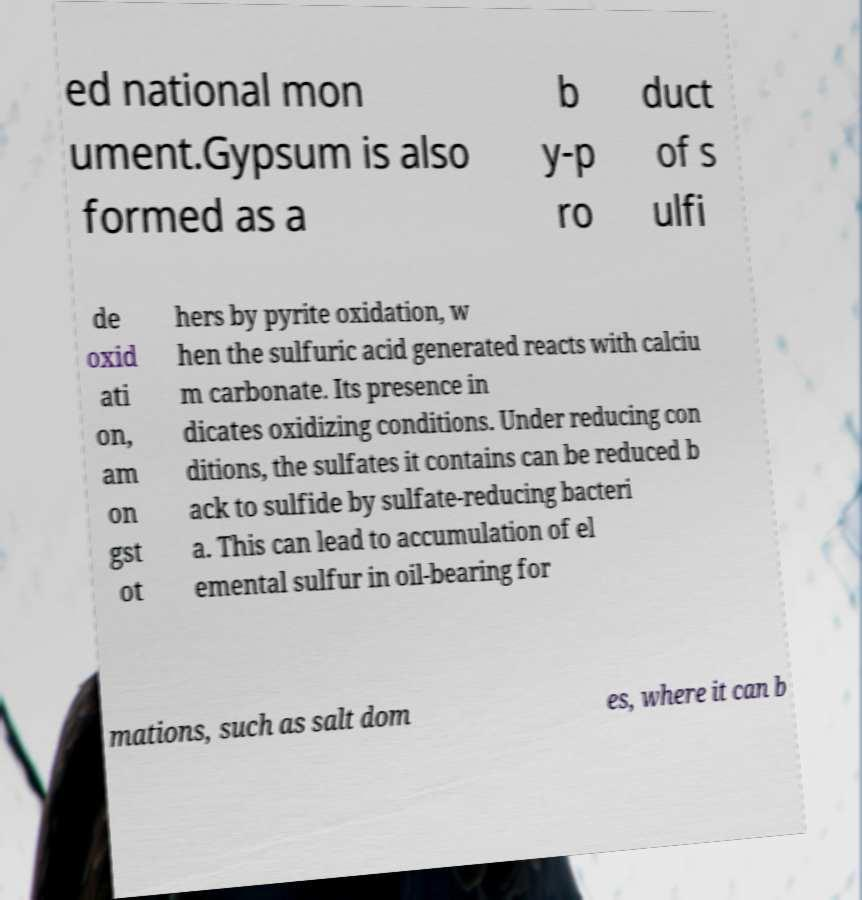Can you accurately transcribe the text from the provided image for me? ed national mon ument.Gypsum is also formed as a b y-p ro duct of s ulfi de oxid ati on, am on gst ot hers by pyrite oxidation, w hen the sulfuric acid generated reacts with calciu m carbonate. Its presence in dicates oxidizing conditions. Under reducing con ditions, the sulfates it contains can be reduced b ack to sulfide by sulfate-reducing bacteri a. This can lead to accumulation of el emental sulfur in oil-bearing for mations, such as salt dom es, where it can b 